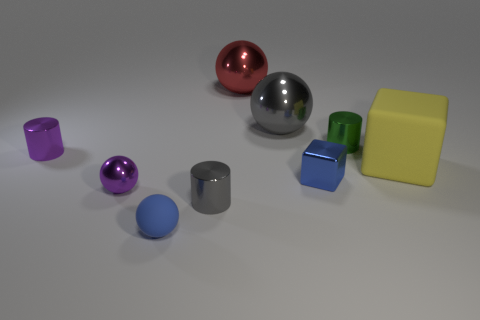Is there a tiny purple shiny thing? Yes, there is a small, shiny, purple object among various colorful objects displayed in the image. 